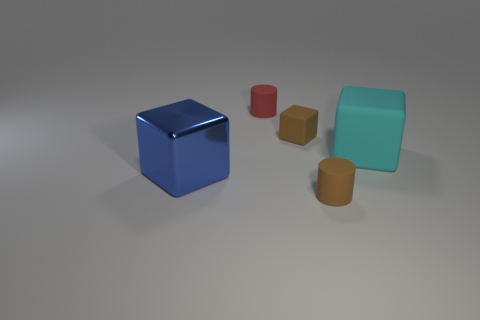What shape is the small thing that is both behind the big blue thing and right of the small red cylinder?
Offer a very short reply. Cube. There is a big object on the right side of the small red cylinder; what color is it?
Offer a terse response. Cyan. Is there anything else of the same color as the large shiny block?
Provide a succinct answer. No. Do the brown cylinder and the cyan matte thing have the same size?
Offer a terse response. No. What is the size of the thing that is both on the right side of the small brown rubber cube and behind the brown cylinder?
Provide a succinct answer. Large. What number of red cylinders have the same material as the big cyan thing?
Give a very brief answer. 1. The tiny rubber thing that is the same color as the tiny matte block is what shape?
Your answer should be compact. Cylinder. What is the color of the shiny cube?
Offer a very short reply. Blue. Do the rubber thing that is behind the brown rubber cube and the blue thing have the same shape?
Your answer should be very brief. No. How many objects are rubber things on the right side of the red matte cylinder or large blue shiny cubes?
Offer a terse response. 4. 